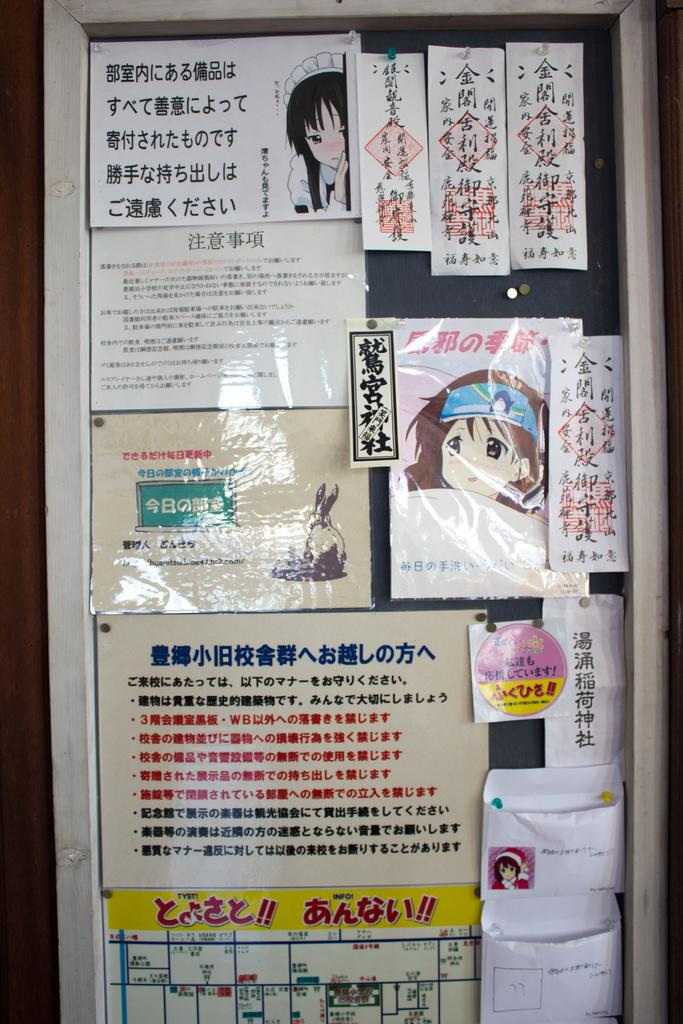What is the main object in the image? There is a board in the image. What is attached to the board? The board has many papers and posters on it. What can be found on the papers? There is text on the papers. What can be found on the posters? There are images on the posters. How does the tin help to reduce the debt in the image? There is no tin or mention of debt in the image; the image only features a board with papers and posters. 